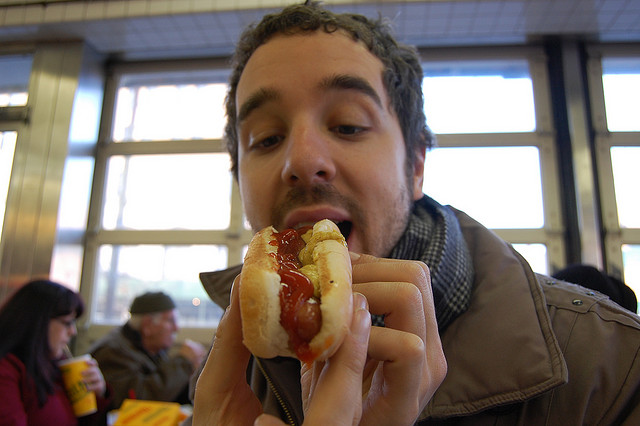What kind of food is the person eating? The person in the image is eating a hot dog, traditionally served in a sliced bun with condiments such as ketchup, as seen here. 